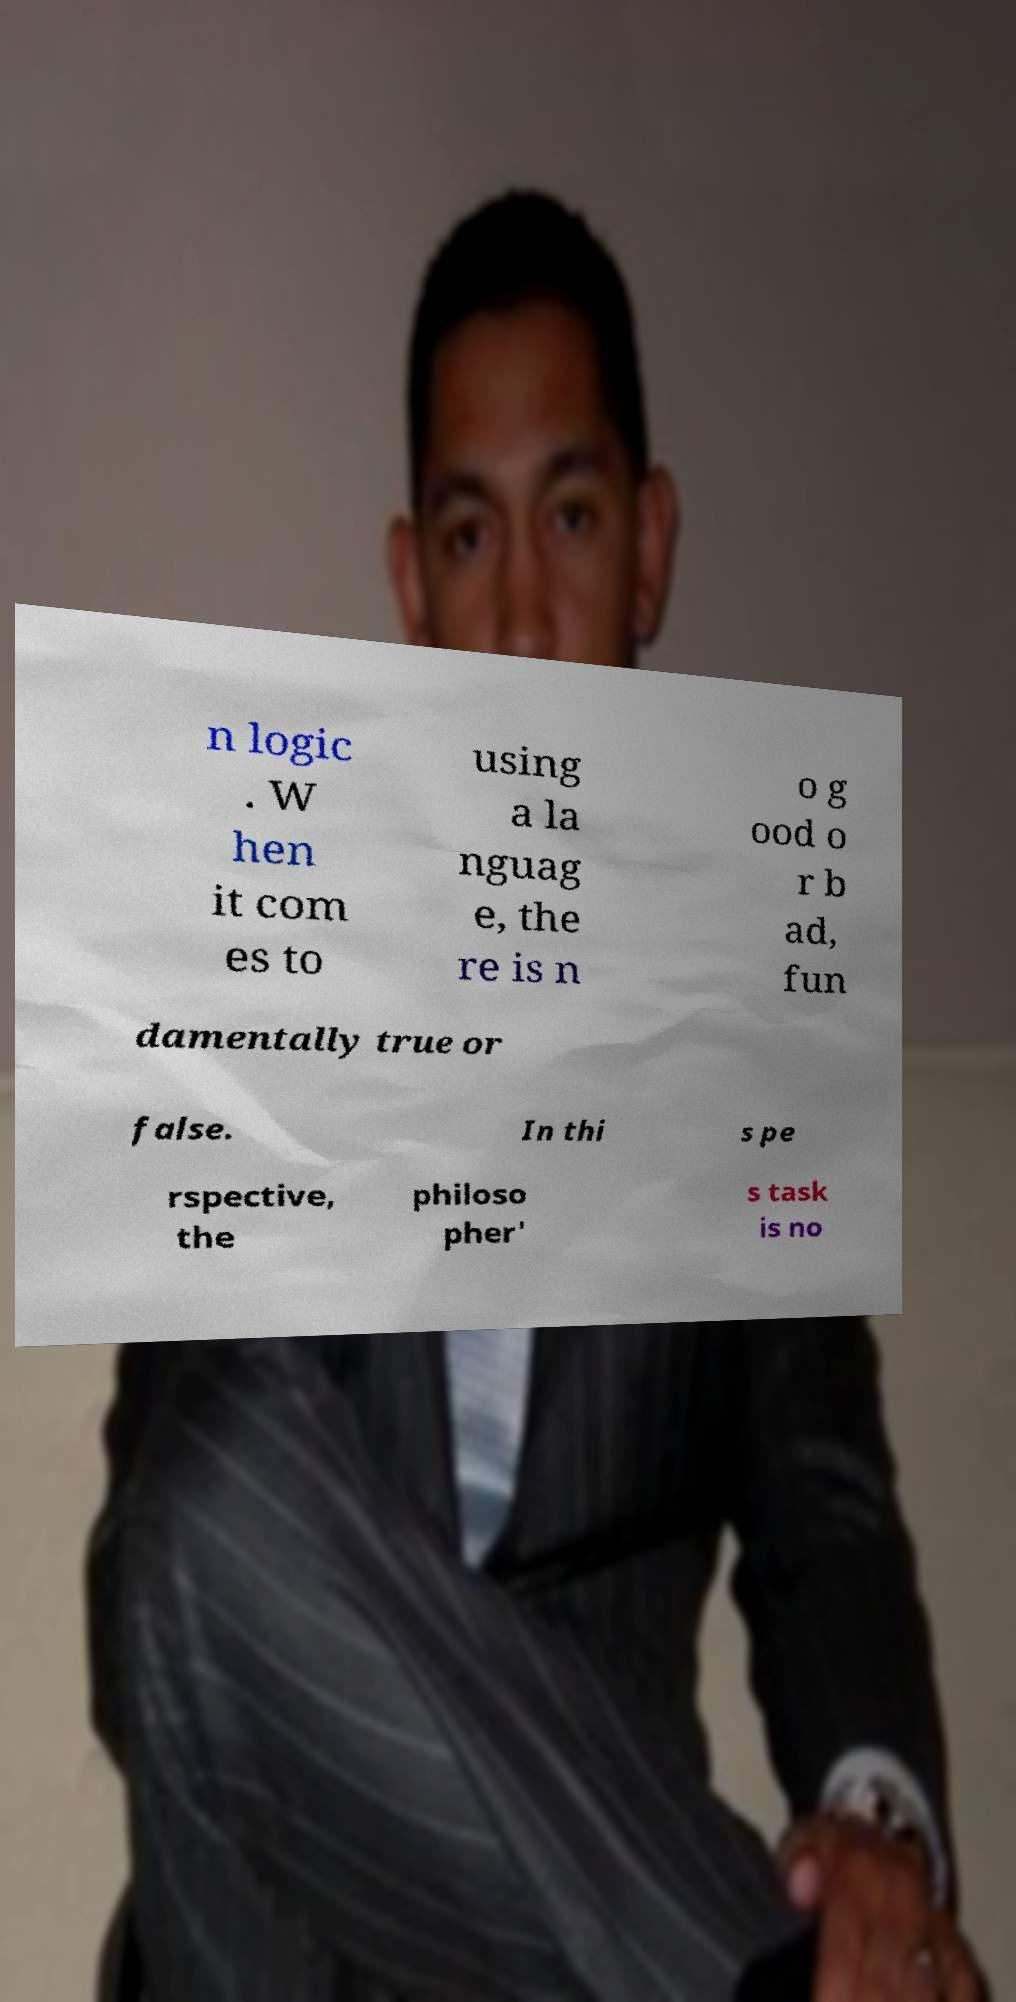Please read and relay the text visible in this image. What does it say? n logic . W hen it com es to using a la nguag e, the re is n o g ood o r b ad, fun damentally true or false. In thi s pe rspective, the philoso pher' s task is no 